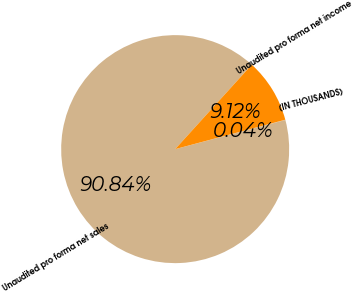Convert chart. <chart><loc_0><loc_0><loc_500><loc_500><pie_chart><fcel>(IN THOUSANDS)<fcel>Unaudited pro forma net sales<fcel>Unaudited pro forma net income<nl><fcel>0.04%<fcel>90.85%<fcel>9.12%<nl></chart> 